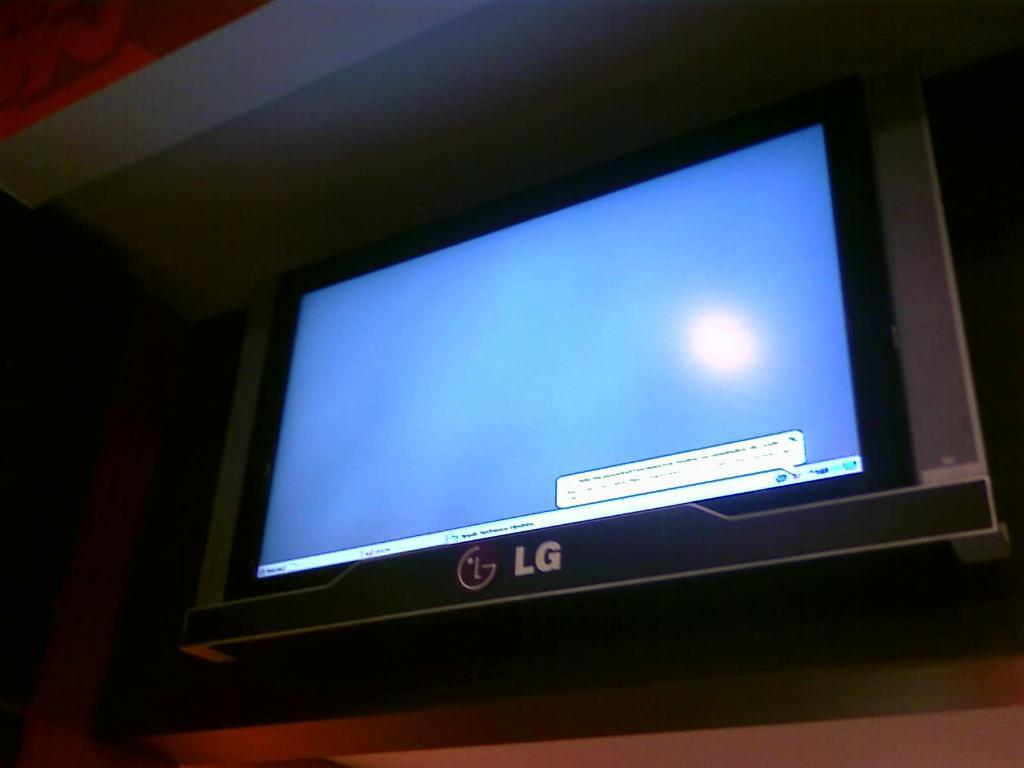Provide a one-sentence caption for the provided image. An LG screen is lit but has no picture. 